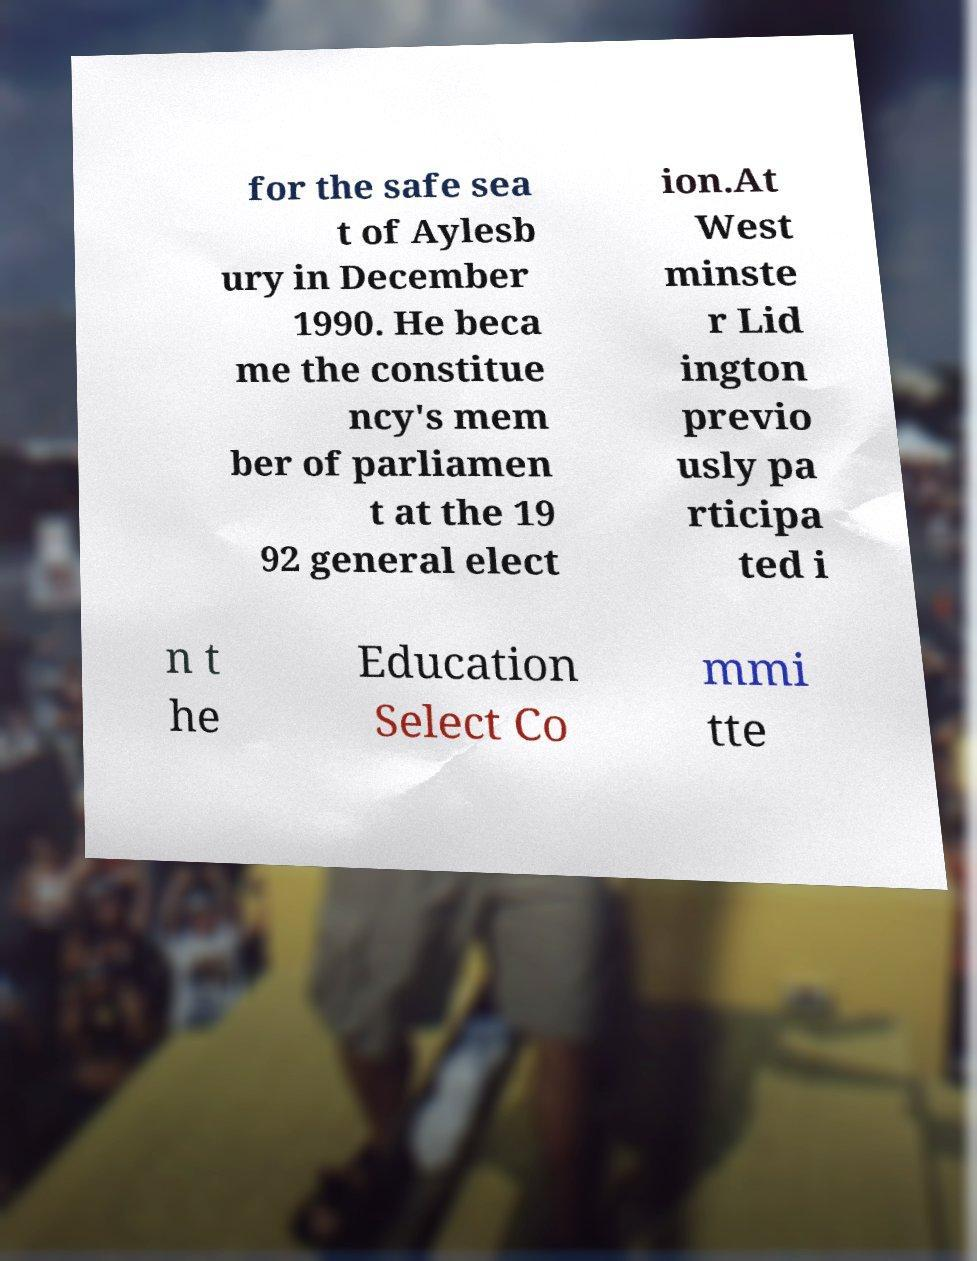I need the written content from this picture converted into text. Can you do that? for the safe sea t of Aylesb ury in December 1990. He beca me the constitue ncy's mem ber of parliamen t at the 19 92 general elect ion.At West minste r Lid ington previo usly pa rticipa ted i n t he Education Select Co mmi tte 